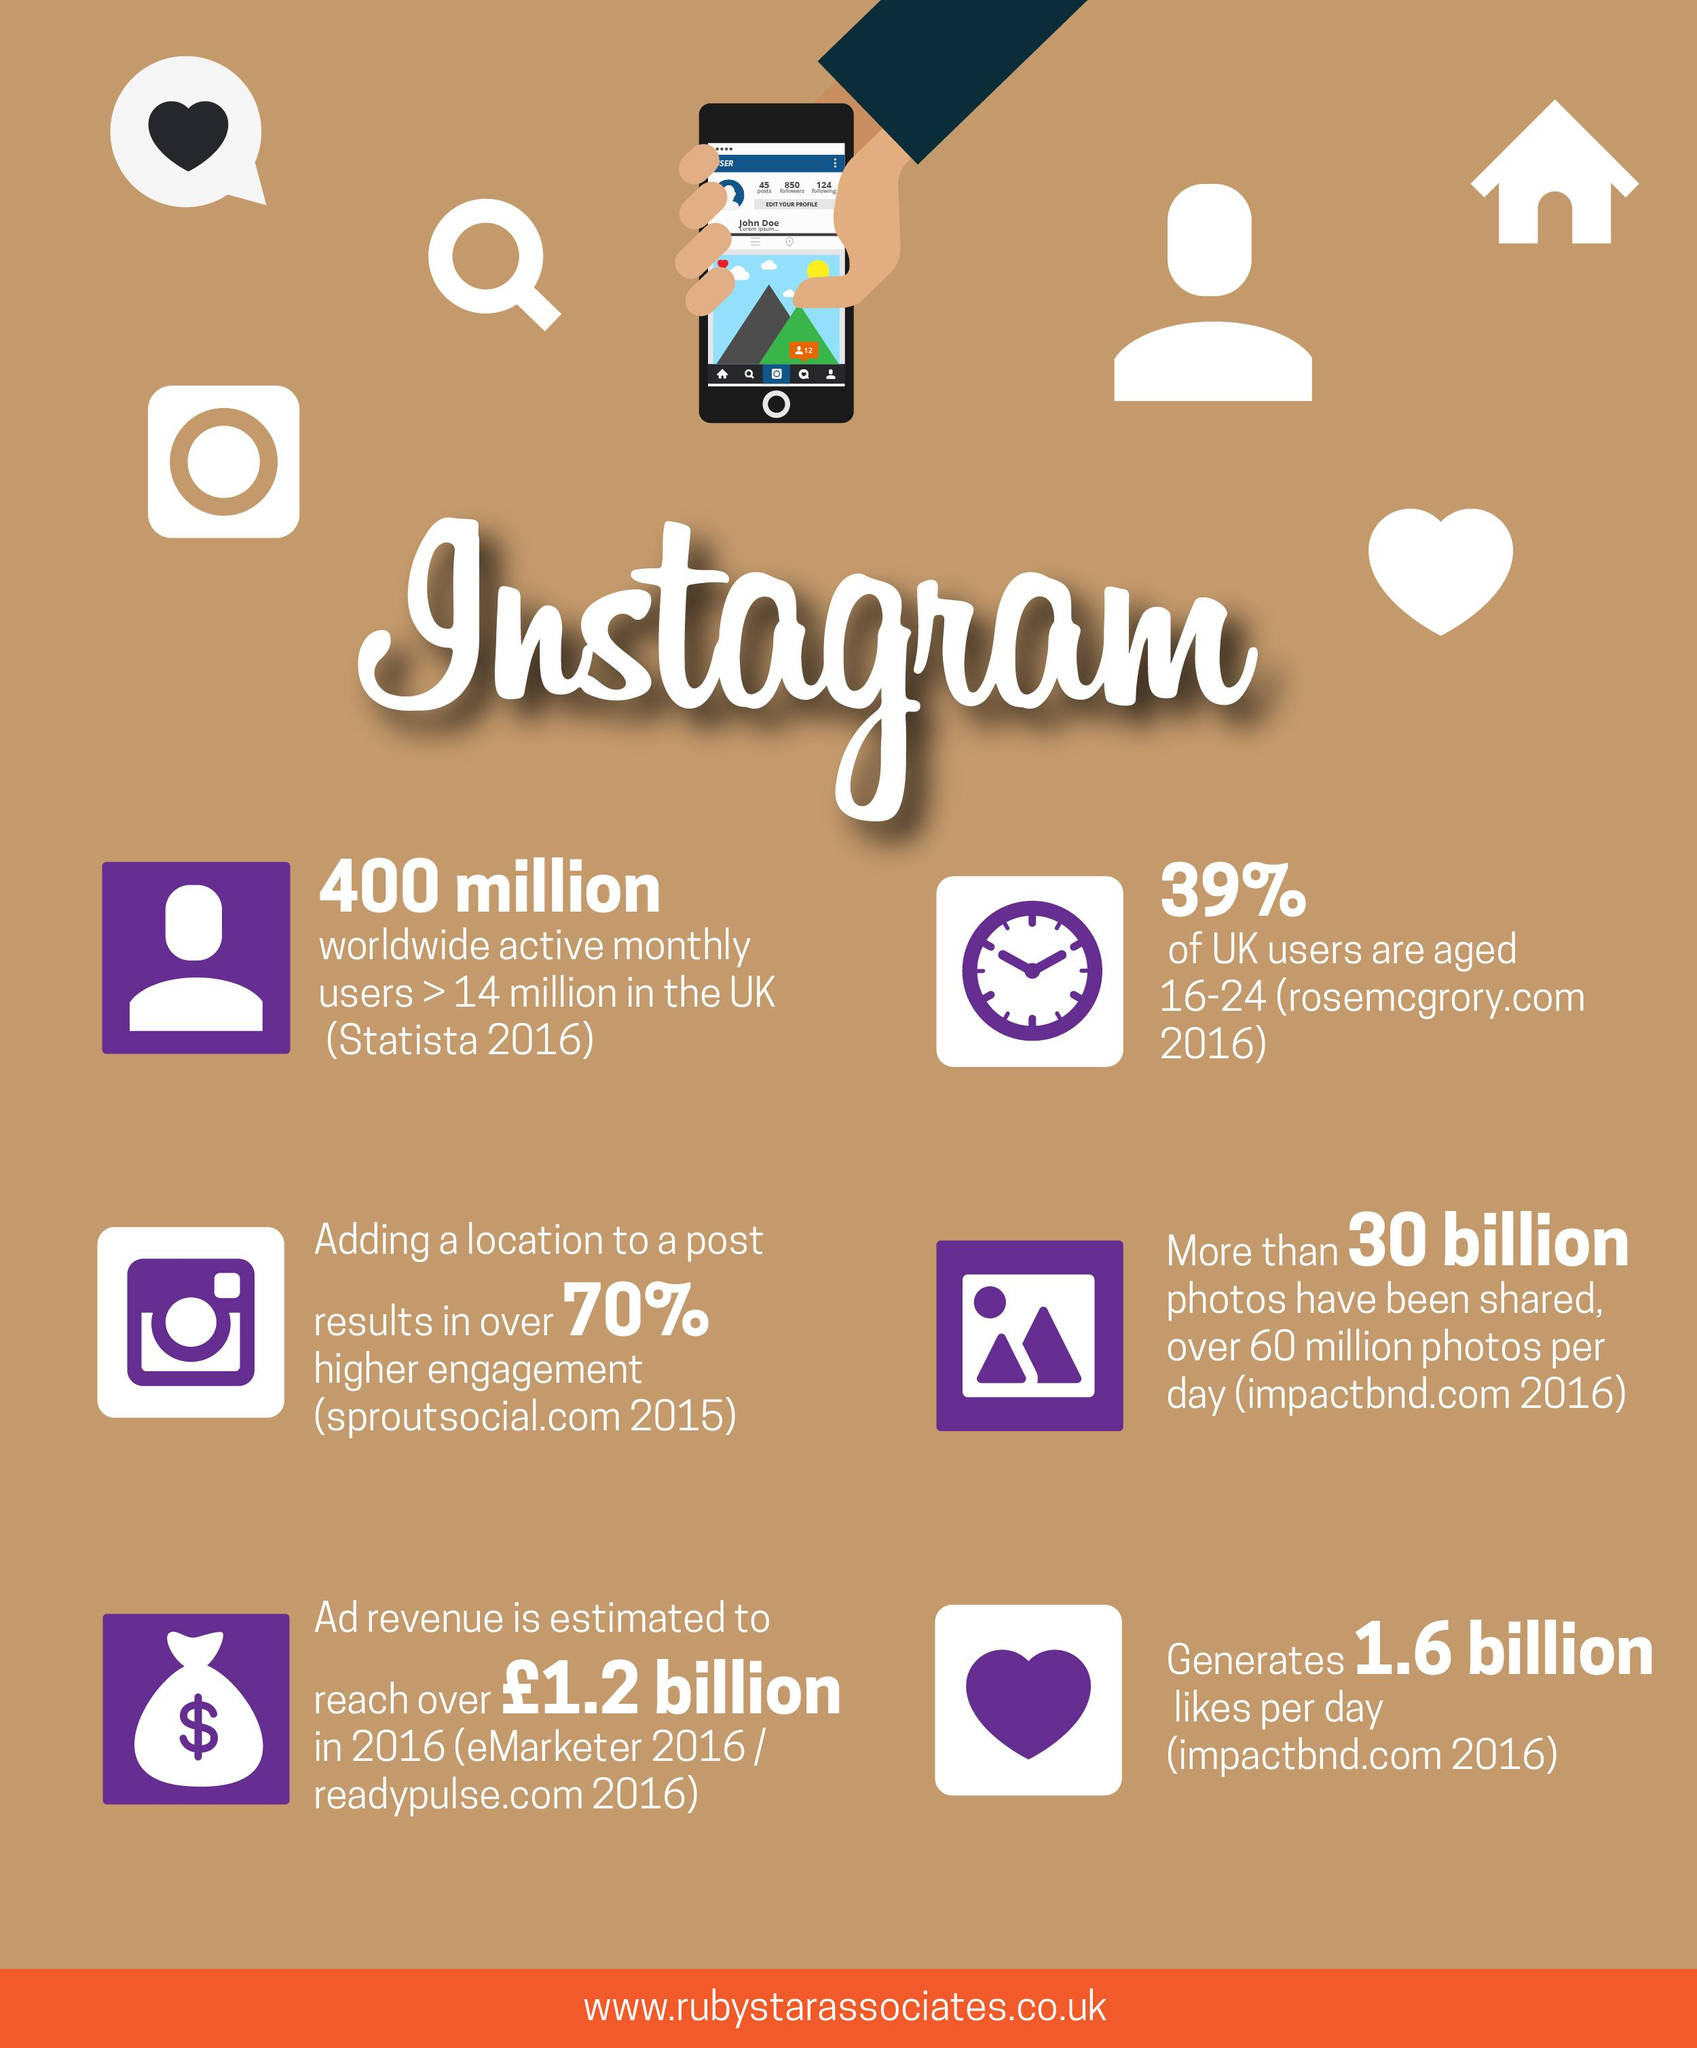Draw attention to some important aspects in this diagram. As of now, a staggering 30 billion photos have been shared through Instagram. According to recent estimates, over 1.6 billion Instagram posts are liked every day. It is important to include a location in an Instagram post in order to increase engagement. According to a recent study, only 39% of Instagram users in the UK fall into the age category of 16-24. 